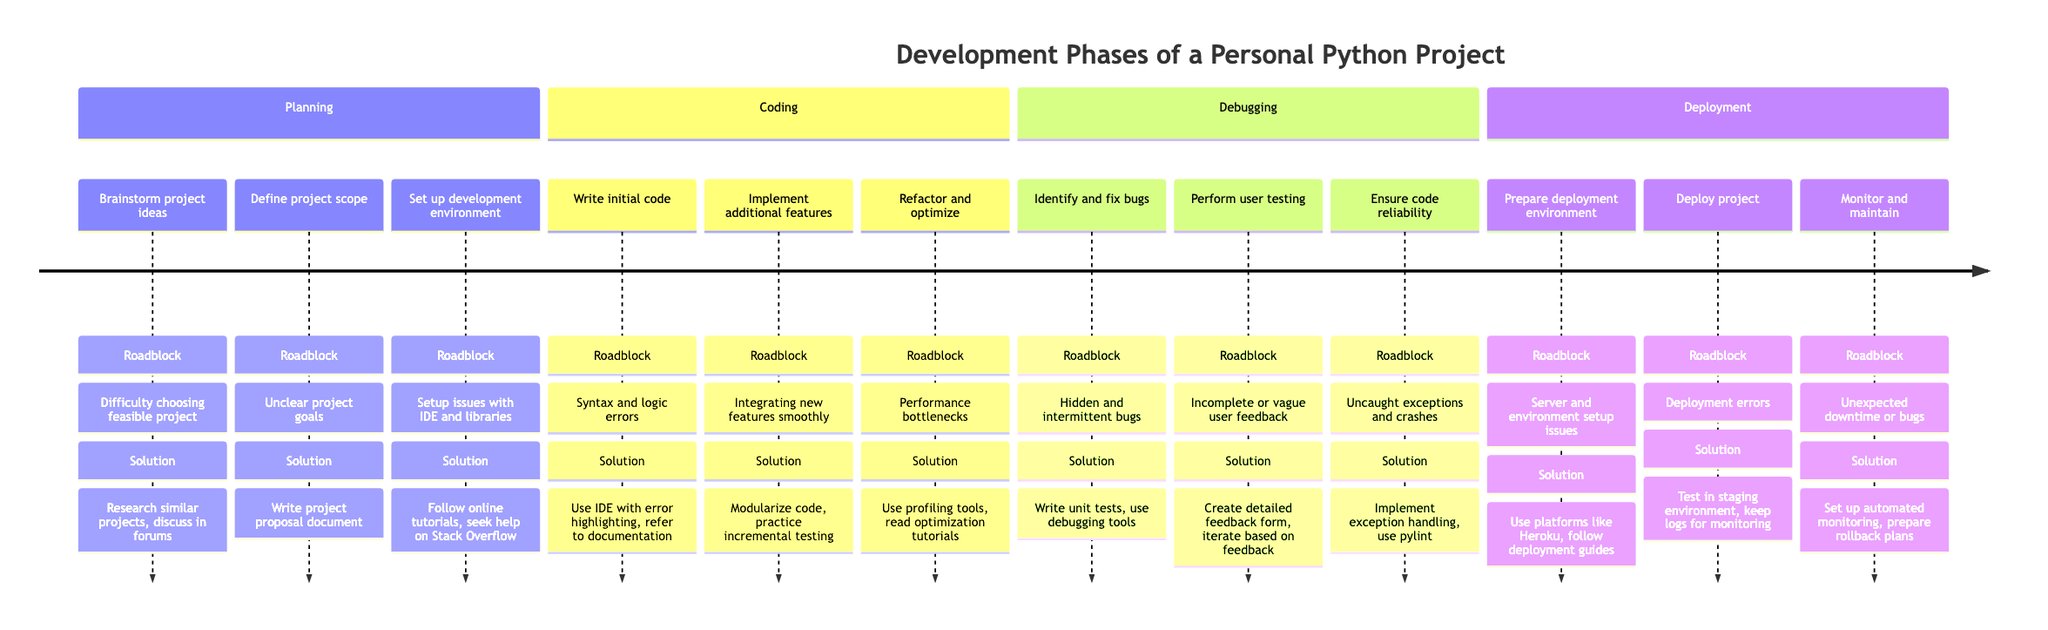What tasks are outlined in the Planning phase? The Planning phase includes three tasks: Brainstorm project ideas, Define project scope and objectives, and Set up a development environment.
Answer: Brainstorm project ideas, Define project scope and objectives, Set up a development environment How many tasks are there in the Coding phase? The Coding phase has three tasks listed: Write initial code for core features, Implement additional functionalities, and Refactor and optimize code. Therefore, the total is three tasks.
Answer: Three What is a roadblock faced during the Debugging phase? One of the roadblocks faced during the Debugging phase is "Hidden and intermittent bugs." This is highlighted under the task "Identify and fix bugs."
Answer: Hidden and intermittent bugs What solutions were implemented for integrating new features smoothly? The solution implemented for integrating new features smoothly was to "Modularize the code, practice incremental testing," which is specified under the task "Implement additional functionalities."
Answer: Modularize the code, practice incremental testing Which deployment task involves unexpected downtime? The task that involves unexpected downtime is "Monitor and maintain deployment," specifically mentioning the roadblock of "Unexpected downtime or bugs."
Answer: Monitor and maintain deployment What is the first task listed under Coding? The first task listed under the Coding phase is "Write initial code for core features." This task is the starting point of that section.
Answer: Write initial code for core features What solutions ensure code reliability and stability? To ensure code reliability and stability, the solutions included "Implement exception handling, use pylint to catch potential issues," which is documented under the task "Ensure code reliability and stability."
Answer: Implement exception handling, use pylint In which phase is user testing performed? User testing is performed in the Debugging phase, as indicated under the task "Perform user testing."
Answer: Debugging What was a roadblock faced while setting up the development environment? The roadblock faced while setting up the development environment was "Setup issues with IDE and Python libraries," mentioned under the task "Set up a development environment."
Answer: Setup issues with IDE and Python libraries 